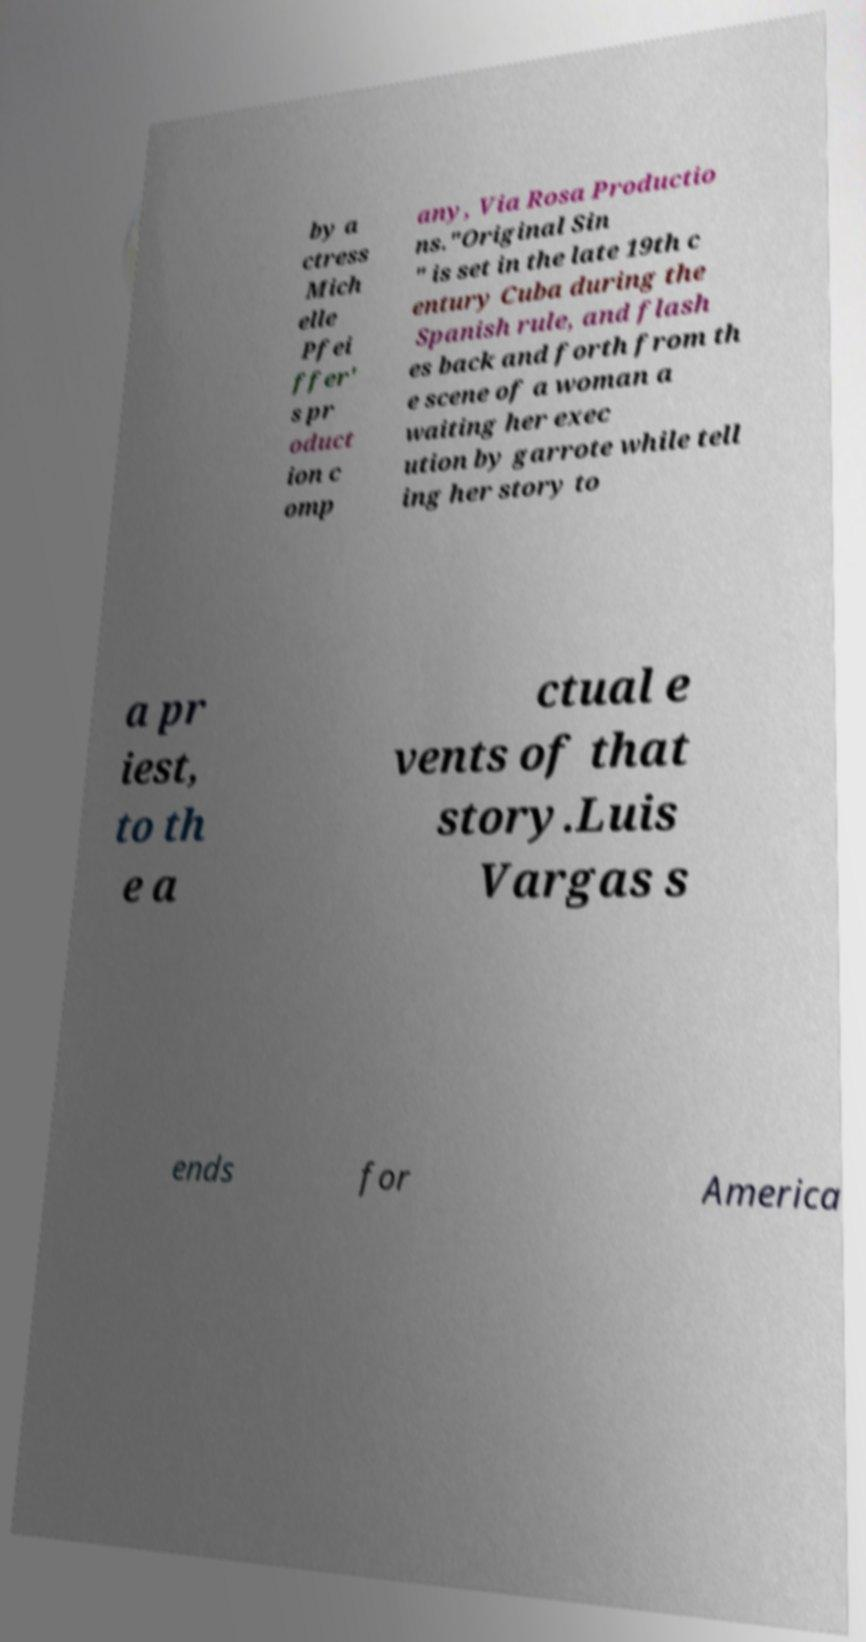Please read and relay the text visible in this image. What does it say? by a ctress Mich elle Pfei ffer' s pr oduct ion c omp any, Via Rosa Productio ns."Original Sin " is set in the late 19th c entury Cuba during the Spanish rule, and flash es back and forth from th e scene of a woman a waiting her exec ution by garrote while tell ing her story to a pr iest, to th e a ctual e vents of that story.Luis Vargas s ends for America 